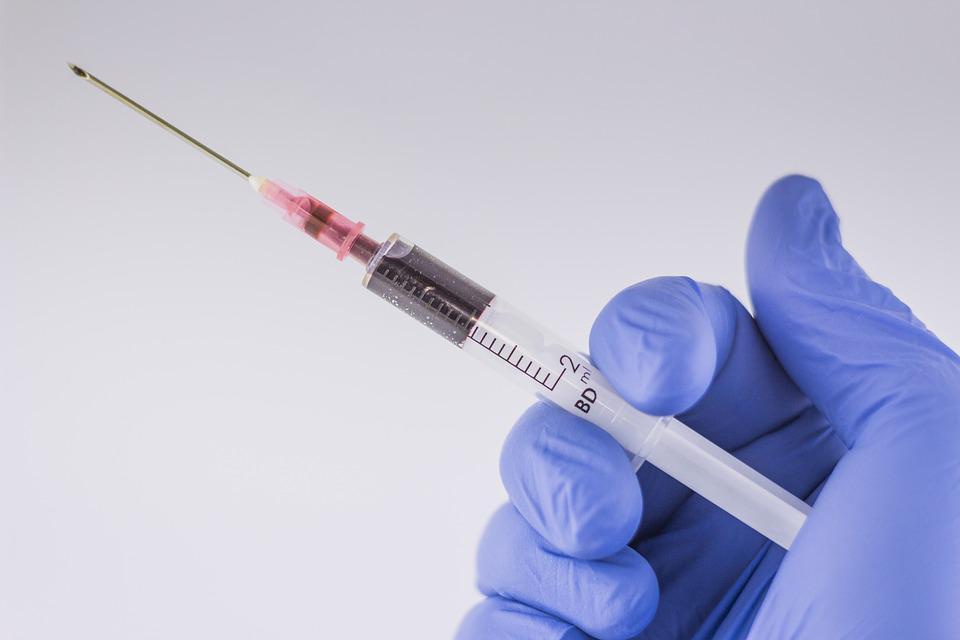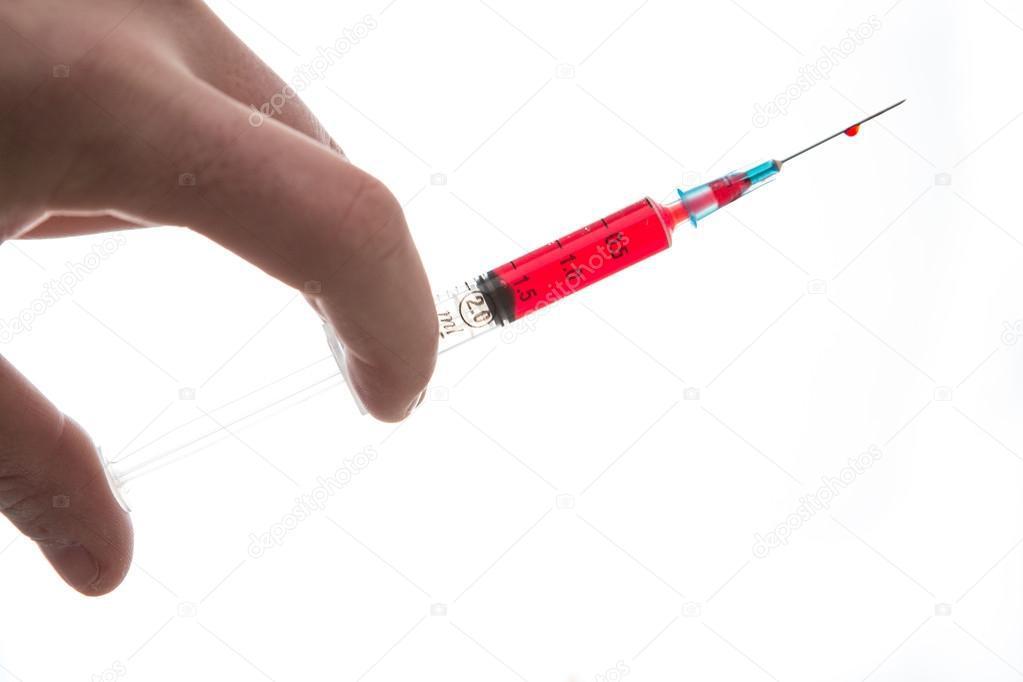The first image is the image on the left, the second image is the image on the right. Examine the images to the left and right. Is the description "There are needles with red liquid and two hands." accurate? Answer yes or no. Yes. The first image is the image on the left, the second image is the image on the right. For the images displayed, is the sentence "A gloved hand holds an uncapped syringe in one image." factually correct? Answer yes or no. Yes. 